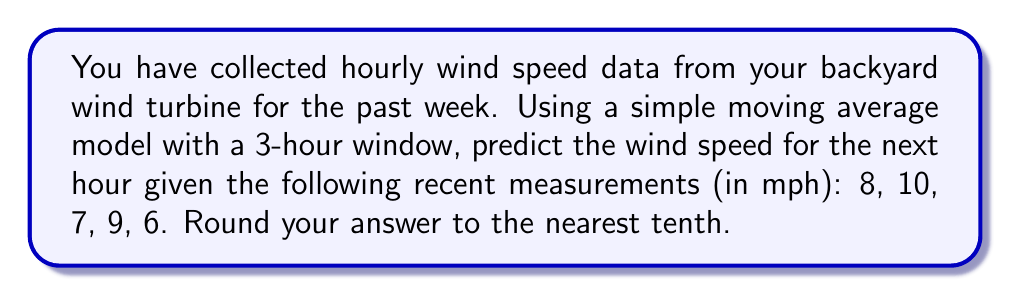Can you solve this math problem? To solve this problem using a simple moving average model with a 3-hour window, we'll follow these steps:

1. Identify the most recent 3 hours of data:
   The most recent 3 measurements are 7, 9, and 6 mph.

2. Calculate the average of these 3 values:
   $$ \text{Average} = \frac{7 + 9 + 6}{3} = \frac{22}{3} \approx 7.3333 $$

3. Round the result to the nearest tenth:
   7.3333 rounded to the nearest tenth is 7.3 mph.

This simple moving average model assumes that the next hour's wind speed will be approximately equal to the average of the previous 3 hours. While this is a basic forecasting technique, it can provide a reasonable short-term prediction for wind speed patterns.

More advanced time series analysis and forecasting techniques, such as ARIMA (Autoregressive Integrated Moving Average) or exponential smoothing methods, could potentially provide more accurate predictions by accounting for trends and seasonality in the wind speed data.
Answer: 7.3 mph 